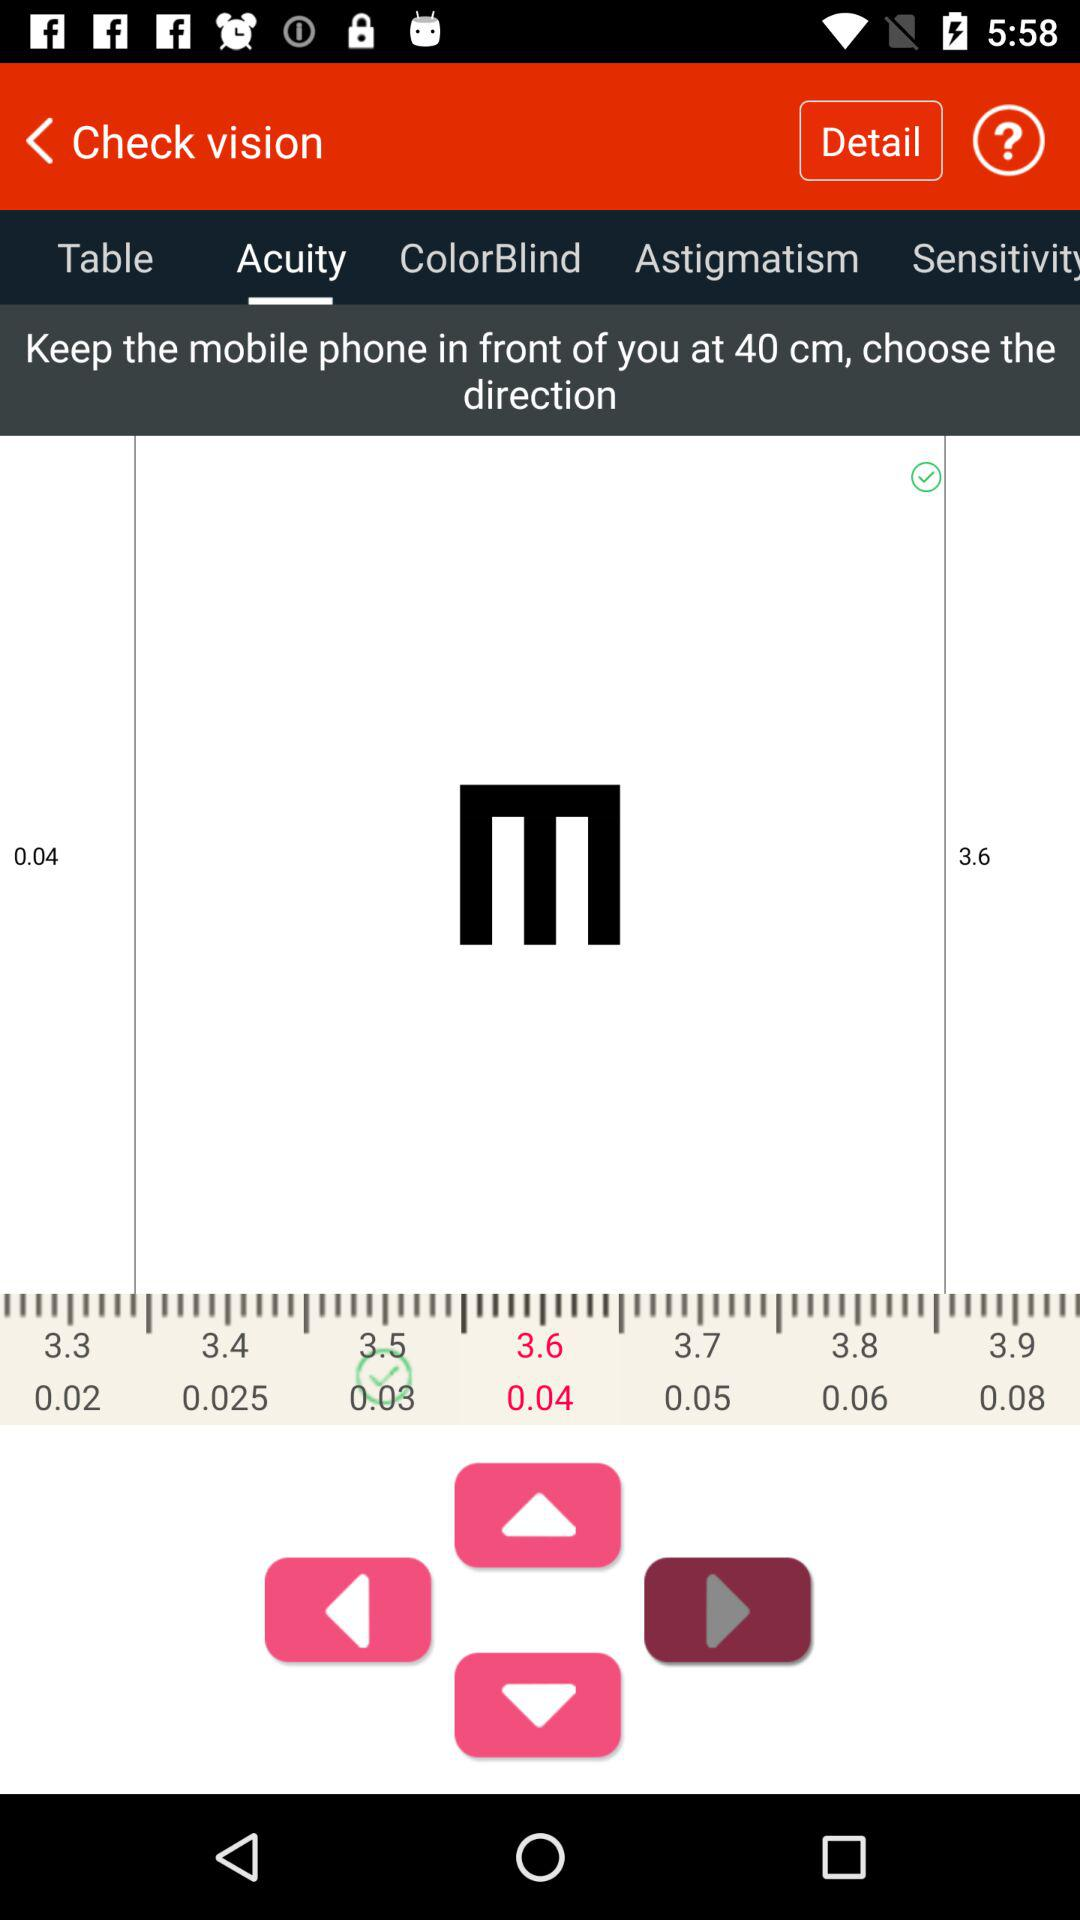Which tab has been selected? The selected tab is "Acuity". 